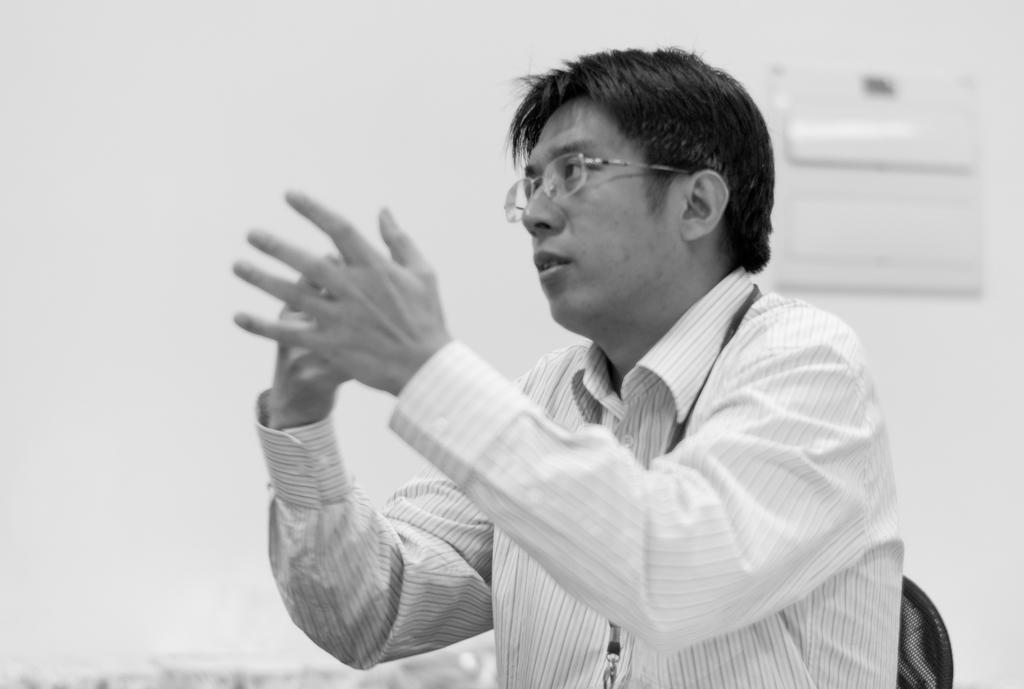What is the color scheme of the image? The image is black and white. Who or what is the main subject in the image? There is a person in the center of the image. What can be seen in the background of the image? There is a wall in the background of the image. What type of honey is being used to cover the person in the image? There is no honey or covering of any kind present in the image; it features a person in the center of the image with a wall in the background. 